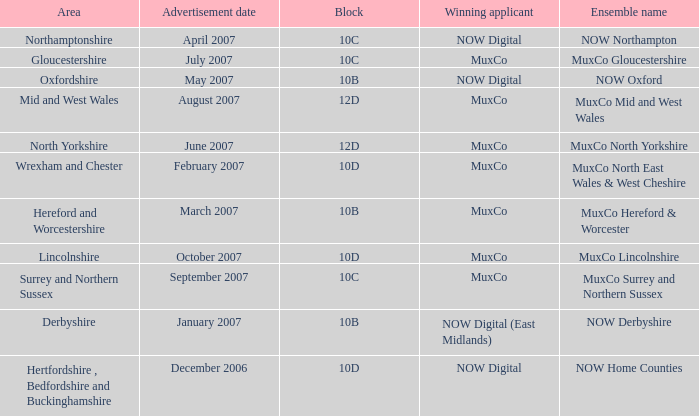Which Block does Northamptonshire Area have? 10C. 